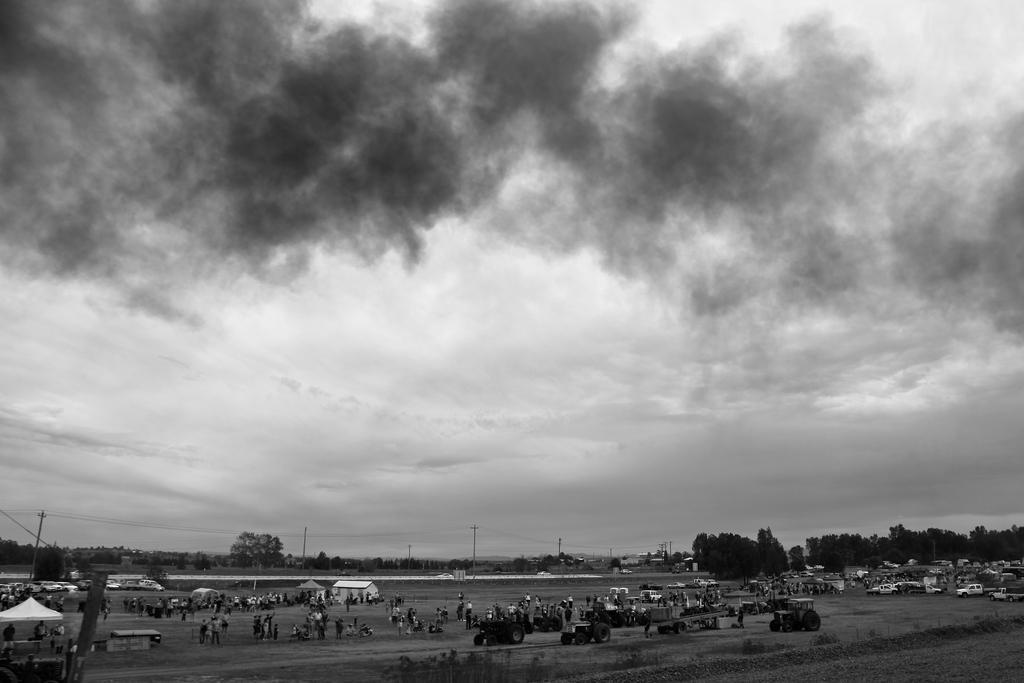How would you summarize this image in a sentence or two? This is a black and white picture. In this picture, we see many people are standing and we even see many vehicles. There are huts and poles. There are street lights, poles, wires and trees in the background. In the left bottom, we see people sitting under the white tent. At the top, we see the sky. 